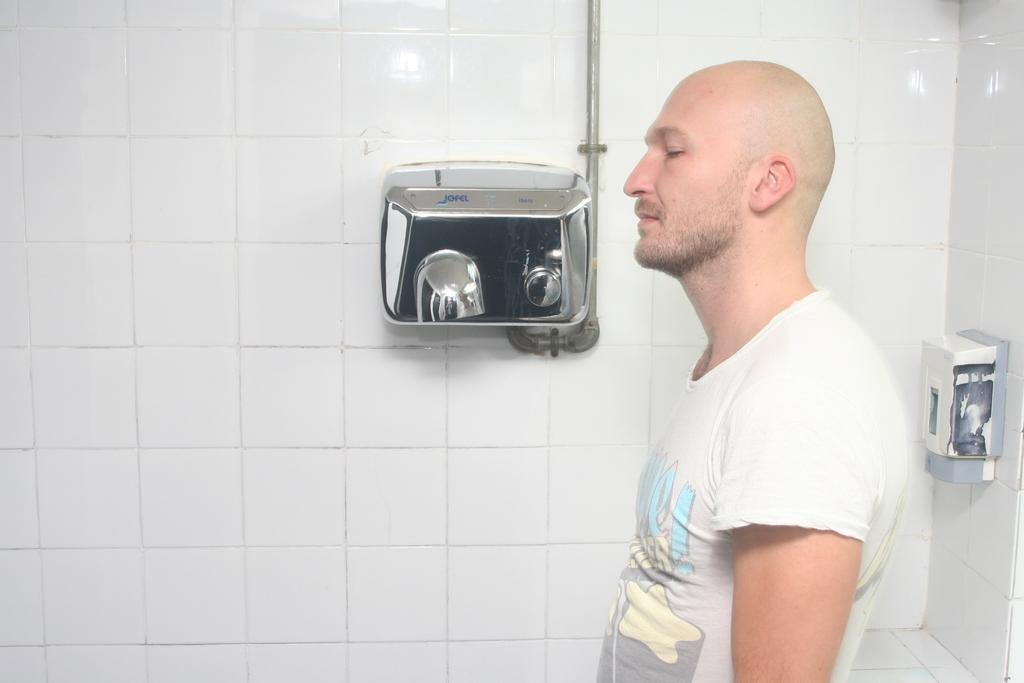Who is present in the image? There is a man in the image. What can be seen on the right side of the image? There is a wall with a soap dispenser on the right side of the image. What is visible in the background of the image? There is a wall with an object in the background of the image. What type of snail can be seen crawling on the wall in the image? There is no snail present in the image; only a man, a wall with a soap dispenser, and a wall with an object are visible. 